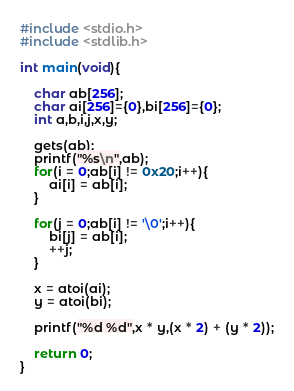Convert code to text. <code><loc_0><loc_0><loc_500><loc_500><_C_>#include <stdio.h>
#include <stdlib.h>

int main(void){

	char ab[256];
	char ai[256]={0},bi[256]={0};
	int a,b,i,j,x,y;
	
	gets(ab);
	printf("%s\n",ab);
	for(i = 0;ab[i] != 0x20;i++){
		ai[i] = ab[i];
	}
	
	for(j = 0;ab[i] != '\0';i++){
		bi[j] = ab[i];
		++j;
	}	
	
	x = atoi(ai);
	y = atoi(bi);
	
	printf("%d %d",x * y,(x * 2) + (y * 2));
	
	return 0;
}</code> 